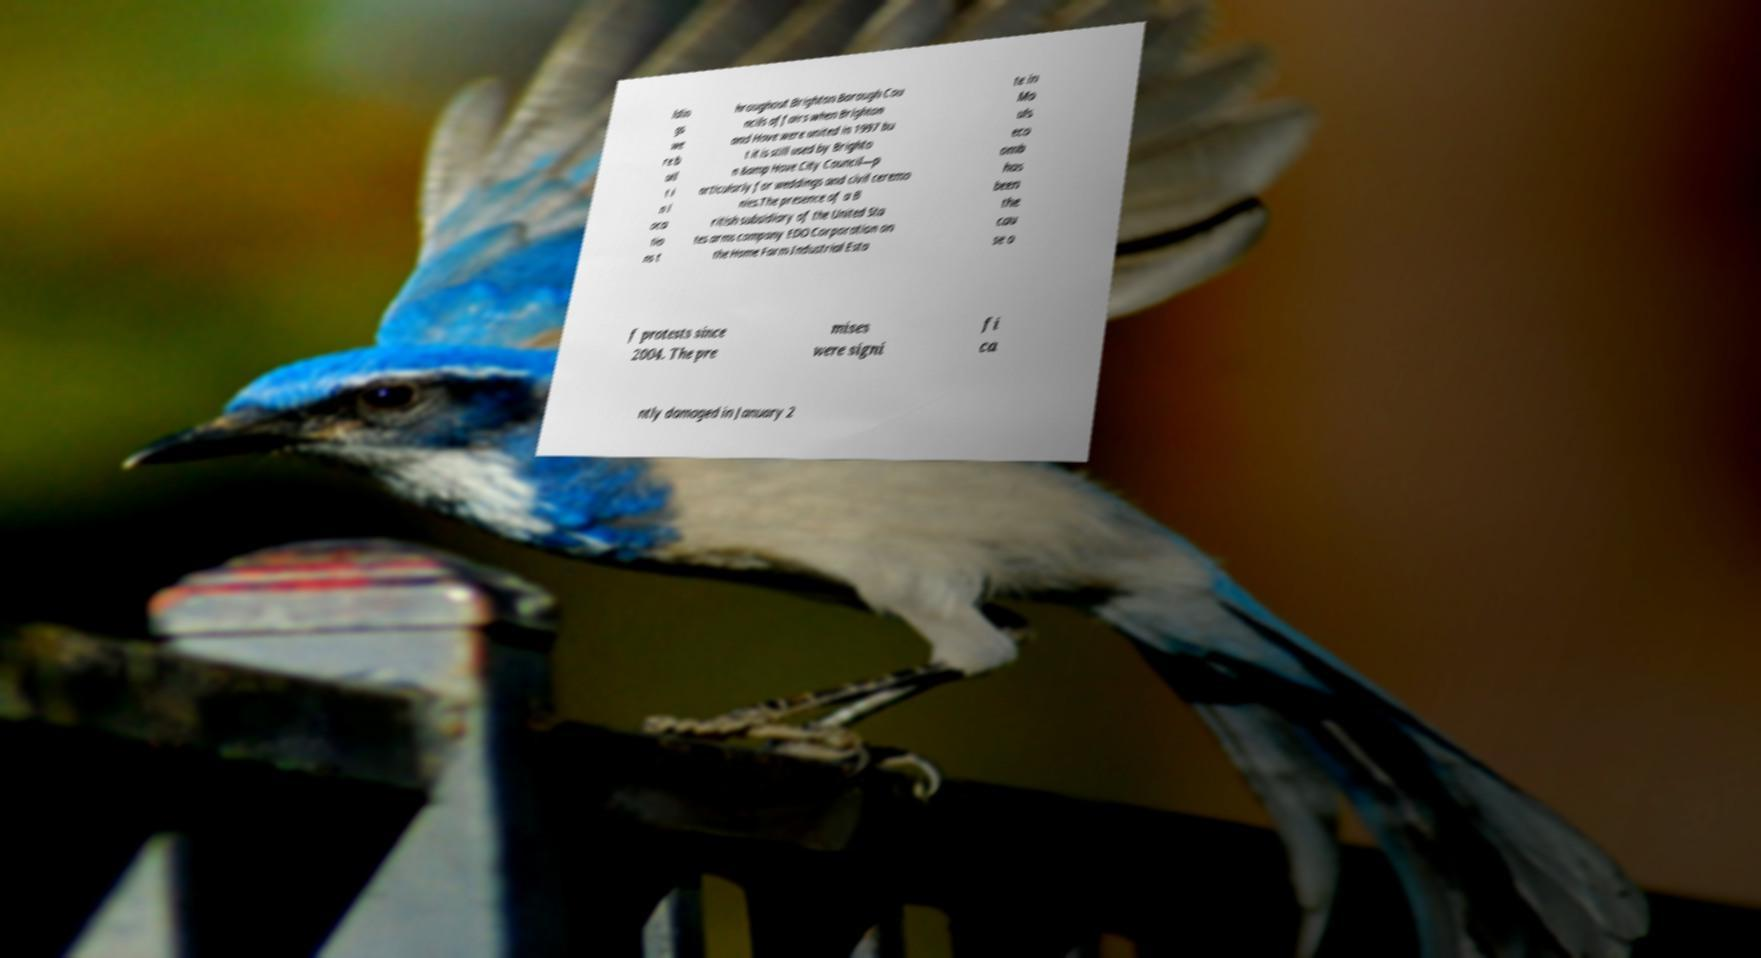There's text embedded in this image that I need extracted. Can you transcribe it verbatim? ldin gs we re b uil t i n l oca tio ns t hroughout Brighton Borough Cou ncils affairs when Brighton and Hove were united in 1997 bu t it is still used by Brighto n &amp Hove City Council—p articularly for weddings and civil ceremo nies.The presence of a B ritish subsidiary of the United Sta tes arms company EDO Corporation on the Home Farm Industrial Esta te in Mo uls eco omb has been the cau se o f protests since 2004. The pre mises were signi fi ca ntly damaged in January 2 